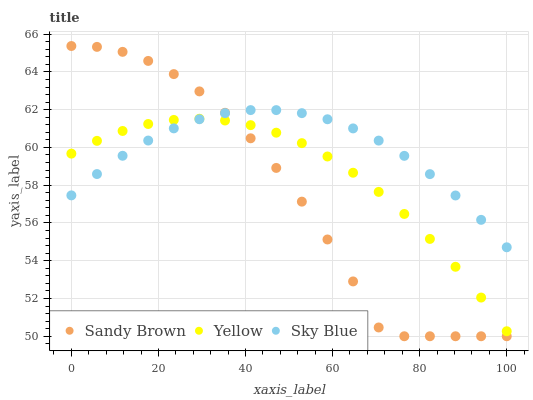Does Sandy Brown have the minimum area under the curve?
Answer yes or no. Yes. Does Sky Blue have the maximum area under the curve?
Answer yes or no. Yes. Does Yellow have the minimum area under the curve?
Answer yes or no. No. Does Yellow have the maximum area under the curve?
Answer yes or no. No. Is Yellow the smoothest?
Answer yes or no. Yes. Is Sandy Brown the roughest?
Answer yes or no. Yes. Is Sandy Brown the smoothest?
Answer yes or no. No. Is Yellow the roughest?
Answer yes or no. No. Does Sandy Brown have the lowest value?
Answer yes or no. Yes. Does Yellow have the lowest value?
Answer yes or no. No. Does Sandy Brown have the highest value?
Answer yes or no. Yes. Does Yellow have the highest value?
Answer yes or no. No. Does Sky Blue intersect Sandy Brown?
Answer yes or no. Yes. Is Sky Blue less than Sandy Brown?
Answer yes or no. No. Is Sky Blue greater than Sandy Brown?
Answer yes or no. No. 